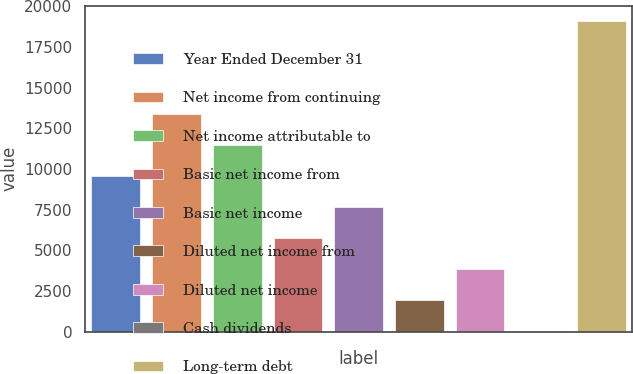Convert chart. <chart><loc_0><loc_0><loc_500><loc_500><bar_chart><fcel>Year Ended December 31<fcel>Net income from continuing<fcel>Net income attributable to<fcel>Basic net income from<fcel>Basic net income<fcel>Diluted net income from<fcel>Diluted net income<fcel>Cash dividends<fcel>Long-term debt<nl><fcel>9551.07<fcel>13371<fcel>11461.1<fcel>5731.09<fcel>7641.08<fcel>1911.11<fcel>3821.1<fcel>1.12<fcel>19101<nl></chart> 